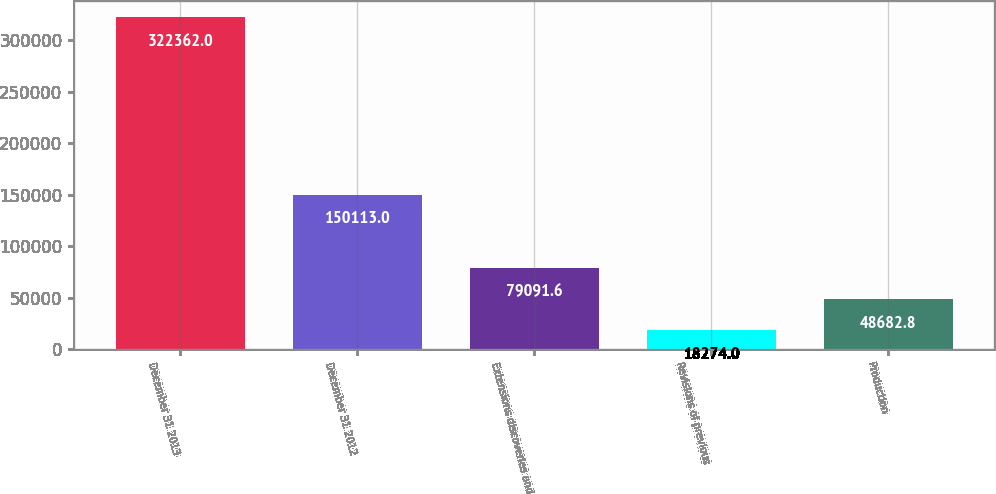<chart> <loc_0><loc_0><loc_500><loc_500><bar_chart><fcel>December 31 2013<fcel>December 31 2012<fcel>Extensions discoveries and<fcel>Revisions of previous<fcel>Production<nl><fcel>322362<fcel>150113<fcel>79091.6<fcel>18274<fcel>48682.8<nl></chart> 